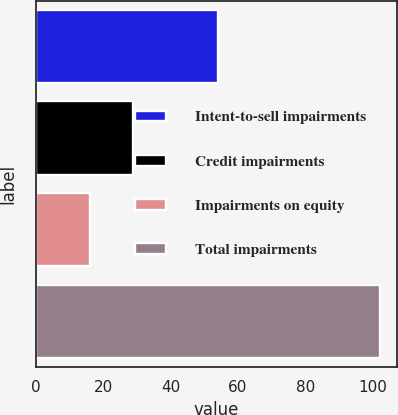Convert chart to OTSL. <chart><loc_0><loc_0><loc_500><loc_500><bar_chart><fcel>Intent-to-sell impairments<fcel>Credit impairments<fcel>Impairments on equity<fcel>Total impairments<nl><fcel>54<fcel>29<fcel>16<fcel>102<nl></chart> 